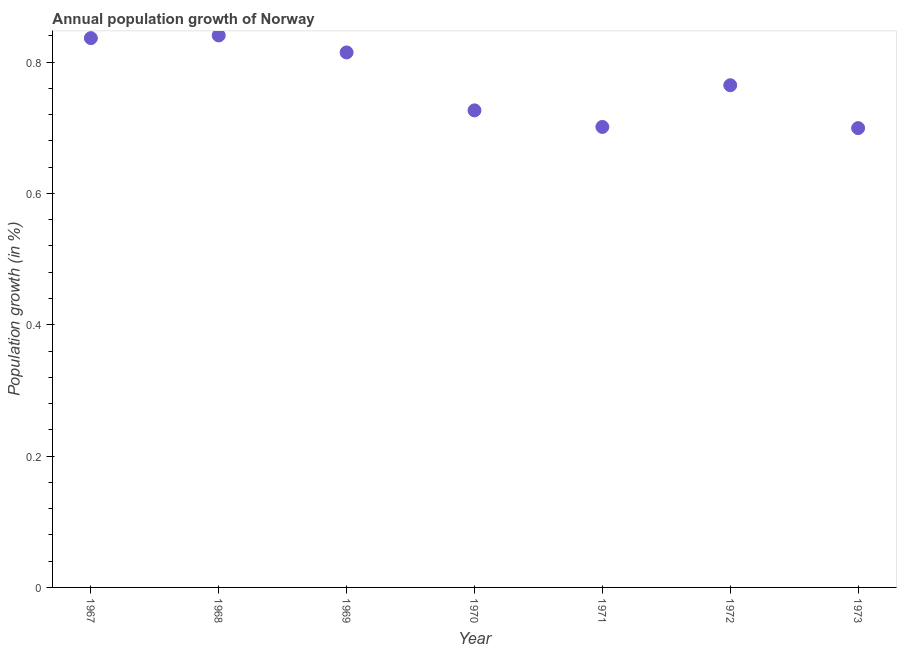What is the population growth in 1971?
Give a very brief answer. 0.7. Across all years, what is the maximum population growth?
Your answer should be very brief. 0.84. Across all years, what is the minimum population growth?
Your response must be concise. 0.7. In which year was the population growth maximum?
Offer a very short reply. 1968. What is the sum of the population growth?
Keep it short and to the point. 5.38. What is the difference between the population growth in 1969 and 1973?
Offer a terse response. 0.12. What is the average population growth per year?
Ensure brevity in your answer.  0.77. What is the median population growth?
Your answer should be very brief. 0.76. Do a majority of the years between 1968 and 1971 (inclusive) have population growth greater than 0.6000000000000001 %?
Offer a very short reply. Yes. What is the ratio of the population growth in 1967 to that in 1973?
Your answer should be very brief. 1.2. What is the difference between the highest and the second highest population growth?
Offer a very short reply. 0. Is the sum of the population growth in 1970 and 1971 greater than the maximum population growth across all years?
Your response must be concise. Yes. What is the difference between the highest and the lowest population growth?
Offer a terse response. 0.14. In how many years, is the population growth greater than the average population growth taken over all years?
Your response must be concise. 3. How many dotlines are there?
Your answer should be compact. 1. What is the difference between two consecutive major ticks on the Y-axis?
Provide a short and direct response. 0.2. Are the values on the major ticks of Y-axis written in scientific E-notation?
Keep it short and to the point. No. Does the graph contain any zero values?
Your response must be concise. No. What is the title of the graph?
Your answer should be very brief. Annual population growth of Norway. What is the label or title of the X-axis?
Give a very brief answer. Year. What is the label or title of the Y-axis?
Your answer should be very brief. Population growth (in %). What is the Population growth (in %) in 1967?
Offer a very short reply. 0.84. What is the Population growth (in %) in 1968?
Your answer should be compact. 0.84. What is the Population growth (in %) in 1969?
Make the answer very short. 0.81. What is the Population growth (in %) in 1970?
Ensure brevity in your answer.  0.73. What is the Population growth (in %) in 1971?
Provide a succinct answer. 0.7. What is the Population growth (in %) in 1972?
Offer a very short reply. 0.76. What is the Population growth (in %) in 1973?
Offer a terse response. 0.7. What is the difference between the Population growth (in %) in 1967 and 1968?
Your answer should be very brief. -0. What is the difference between the Population growth (in %) in 1967 and 1969?
Provide a succinct answer. 0.02. What is the difference between the Population growth (in %) in 1967 and 1970?
Provide a short and direct response. 0.11. What is the difference between the Population growth (in %) in 1967 and 1971?
Your response must be concise. 0.14. What is the difference between the Population growth (in %) in 1967 and 1972?
Offer a very short reply. 0.07. What is the difference between the Population growth (in %) in 1967 and 1973?
Provide a short and direct response. 0.14. What is the difference between the Population growth (in %) in 1968 and 1969?
Offer a terse response. 0.03. What is the difference between the Population growth (in %) in 1968 and 1970?
Your response must be concise. 0.11. What is the difference between the Population growth (in %) in 1968 and 1971?
Ensure brevity in your answer.  0.14. What is the difference between the Population growth (in %) in 1968 and 1972?
Your response must be concise. 0.08. What is the difference between the Population growth (in %) in 1968 and 1973?
Keep it short and to the point. 0.14. What is the difference between the Population growth (in %) in 1969 and 1970?
Offer a very short reply. 0.09. What is the difference between the Population growth (in %) in 1969 and 1971?
Your answer should be compact. 0.11. What is the difference between the Population growth (in %) in 1969 and 1972?
Keep it short and to the point. 0.05. What is the difference between the Population growth (in %) in 1969 and 1973?
Offer a terse response. 0.12. What is the difference between the Population growth (in %) in 1970 and 1971?
Your response must be concise. 0.03. What is the difference between the Population growth (in %) in 1970 and 1972?
Ensure brevity in your answer.  -0.04. What is the difference between the Population growth (in %) in 1970 and 1973?
Offer a terse response. 0.03. What is the difference between the Population growth (in %) in 1971 and 1972?
Your answer should be very brief. -0.06. What is the difference between the Population growth (in %) in 1971 and 1973?
Your answer should be compact. 0. What is the difference between the Population growth (in %) in 1972 and 1973?
Give a very brief answer. 0.07. What is the ratio of the Population growth (in %) in 1967 to that in 1968?
Your answer should be compact. 0.99. What is the ratio of the Population growth (in %) in 1967 to that in 1969?
Your response must be concise. 1.03. What is the ratio of the Population growth (in %) in 1967 to that in 1970?
Offer a very short reply. 1.15. What is the ratio of the Population growth (in %) in 1967 to that in 1971?
Your response must be concise. 1.19. What is the ratio of the Population growth (in %) in 1967 to that in 1972?
Your response must be concise. 1.09. What is the ratio of the Population growth (in %) in 1967 to that in 1973?
Give a very brief answer. 1.2. What is the ratio of the Population growth (in %) in 1968 to that in 1969?
Keep it short and to the point. 1.03. What is the ratio of the Population growth (in %) in 1968 to that in 1970?
Your answer should be very brief. 1.16. What is the ratio of the Population growth (in %) in 1968 to that in 1971?
Provide a short and direct response. 1.2. What is the ratio of the Population growth (in %) in 1968 to that in 1972?
Your answer should be very brief. 1.1. What is the ratio of the Population growth (in %) in 1968 to that in 1973?
Keep it short and to the point. 1.2. What is the ratio of the Population growth (in %) in 1969 to that in 1970?
Your response must be concise. 1.12. What is the ratio of the Population growth (in %) in 1969 to that in 1971?
Your answer should be compact. 1.16. What is the ratio of the Population growth (in %) in 1969 to that in 1972?
Provide a short and direct response. 1.06. What is the ratio of the Population growth (in %) in 1969 to that in 1973?
Provide a succinct answer. 1.17. What is the ratio of the Population growth (in %) in 1970 to that in 1971?
Offer a very short reply. 1.04. What is the ratio of the Population growth (in %) in 1970 to that in 1972?
Provide a short and direct response. 0.95. What is the ratio of the Population growth (in %) in 1970 to that in 1973?
Provide a short and direct response. 1.04. What is the ratio of the Population growth (in %) in 1971 to that in 1972?
Keep it short and to the point. 0.92. What is the ratio of the Population growth (in %) in 1971 to that in 1973?
Make the answer very short. 1. What is the ratio of the Population growth (in %) in 1972 to that in 1973?
Make the answer very short. 1.09. 